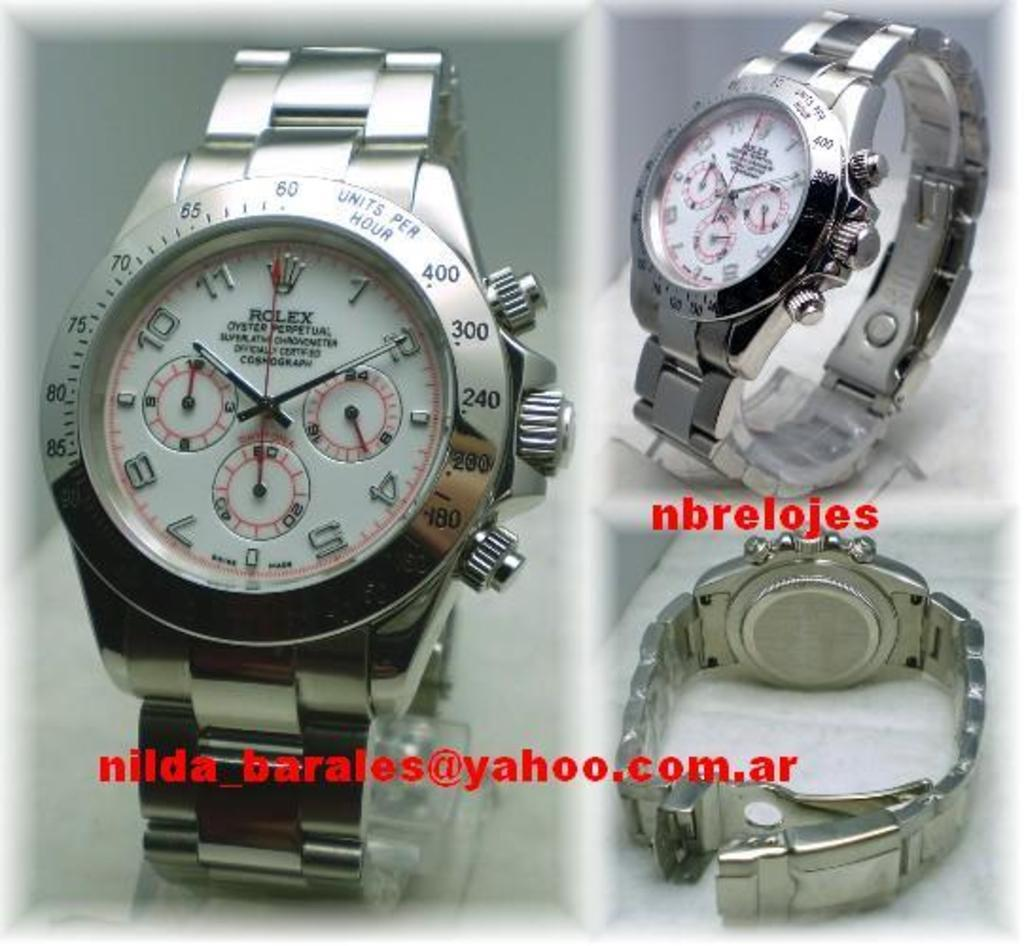<image>
Relay a brief, clear account of the picture shown. A silver Rolex watch read ten minutes after ten. 